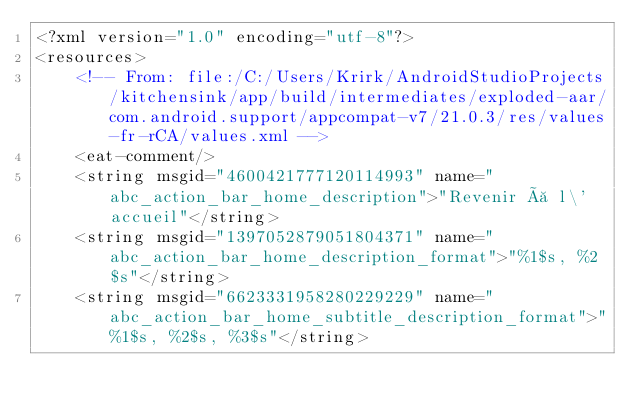<code> <loc_0><loc_0><loc_500><loc_500><_XML_><?xml version="1.0" encoding="utf-8"?>
<resources>
    <!-- From: file:/C:/Users/Krirk/AndroidStudioProjects/kitchensink/app/build/intermediates/exploded-aar/com.android.support/appcompat-v7/21.0.3/res/values-fr-rCA/values.xml -->
    <eat-comment/>
    <string msgid="4600421777120114993" name="abc_action_bar_home_description">"Revenir à l\'accueil"</string>
    <string msgid="1397052879051804371" name="abc_action_bar_home_description_format">"%1$s, %2$s"</string>
    <string msgid="6623331958280229229" name="abc_action_bar_home_subtitle_description_format">"%1$s, %2$s, %3$s"</string></code> 